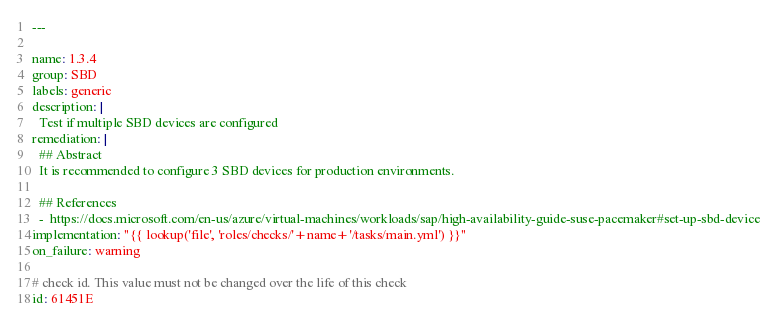<code> <loc_0><loc_0><loc_500><loc_500><_YAML_>---

name: 1.3.4
group: SBD
labels: generic
description: |
  Test if multiple SBD devices are configured
remediation: |
  ## Abstract
  It is recommended to configure 3 SBD devices for production environments.

  ## References
  -  https://docs.microsoft.com/en-us/azure/virtual-machines/workloads/sap/high-availability-guide-suse-pacemaker#set-up-sbd-device
implementation: "{{ lookup('file', 'roles/checks/'+name+'/tasks/main.yml') }}"
on_failure: warning

# check id. This value must not be changed over the life of this check
id: 61451E
</code> 